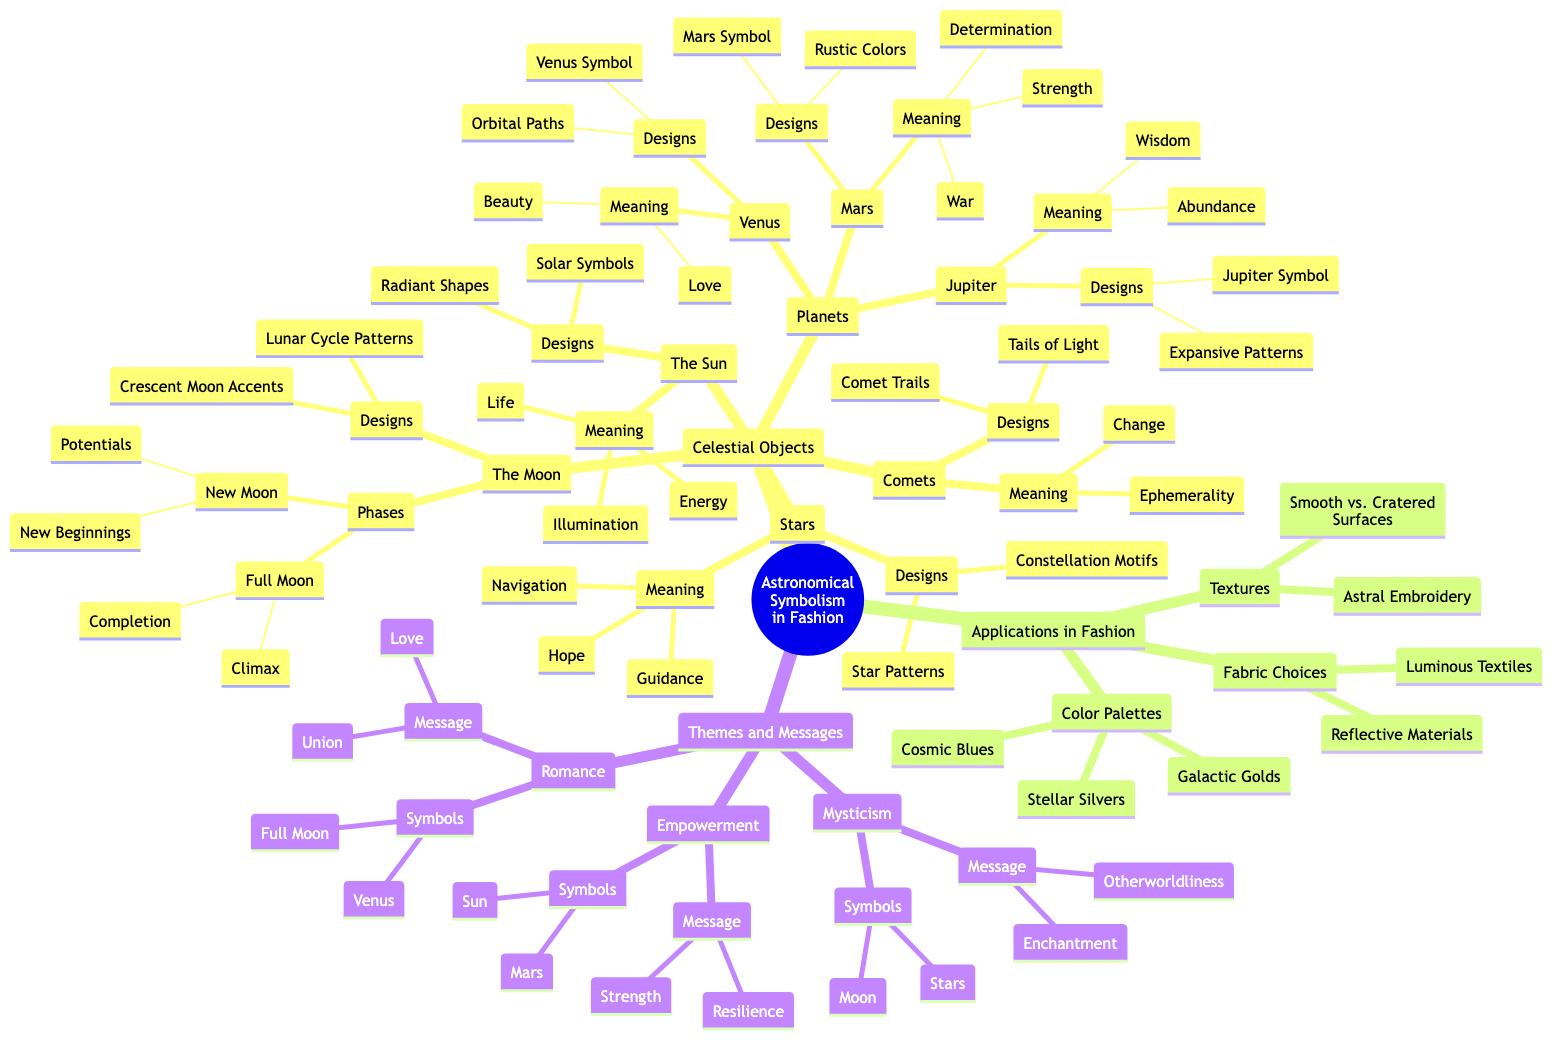What celestial object represents guidance? In the diagram, under the "Stars" node, the list of meanings includes "Guidance." This indicates that the star as a celestial object symbolizes guidance.
Answer: Guidance How many planets are represented in the diagram? The "Planets" node branches into three specific planets: Venus, Mars, and Jupiter. Therefore, the total count of represented planets is three.
Answer: 3 What is the design associated with the Full Moon? Under the "The Moon" node, the "Full Moon" phase is linked to the design "Crescent Moon Accents" and "Lunar Cycle Patterns." Thus, one of the designs associated with the Full Moon is "Crescent Moon Accents."
Answer: Crescent Moon Accents What message is conveyed by the Sun symbolism in fashion? The "Sun" node under "Themes and Messages" is associated with the message of "Strength" and "Resilience." Therefore, it symbolizes empowerment as the key message conveyed.
Answer: Strength Which celestial objects symbolize romance? The "Romance" theme indicates that Venus and the Full Moon are the symbols of romance, connecting celestial themes to the idea of love and union.
Answer: Venus, Full Moon What is the primary meaning associated with Jupiter? Within the "Planets" section, the meanings associated with Jupiter include "Abundance" and "Wisdom." Taking the first listed meaning answers the question as "Abundance."
Answer: Abundance What type of fabrics are suggested in fashion applications? The "Applications in Fashion" node lists fabric choices including "Luminous Textiles" and "Reflective Materials." Therefore, one example of suggested fabric types is "Luminous Textiles."
Answer: Luminous Textiles What is the theme associated with the stars? Under the "Themes and Messages" node, the theme of mysticism is specifically linked with the symbols of "Stars" and "Moon," highlighting its mystical essence. Therefore, the main theme associated with stars is "Mysticism."
Answer: Mysticism What meaning do comets represent? The "Comets" node details their meaning as "Ephemerality" and "Change." For brevity, their primary meaning is identified as "Ephemerality."
Answer: Ephemerality 